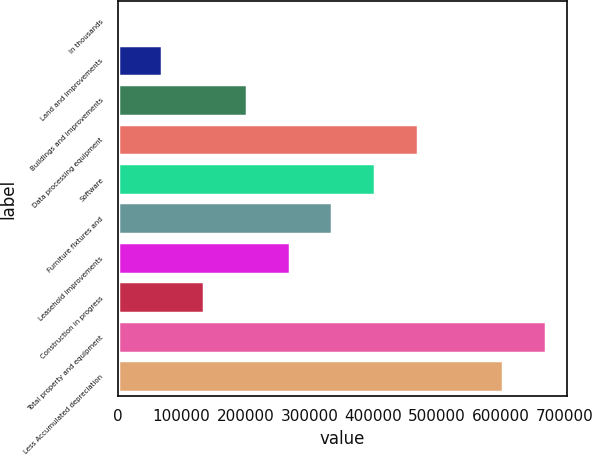Convert chart. <chart><loc_0><loc_0><loc_500><loc_500><bar_chart><fcel>In thousands<fcel>Land and improvements<fcel>Buildings and improvements<fcel>Data processing equipment<fcel>Software<fcel>Furniture fixtures and<fcel>Leasehold improvements<fcel>Construction in progress<fcel>Total property and equipment<fcel>Less Accumulated depreciation<nl><fcel>2009<fcel>68808.8<fcel>202408<fcel>469608<fcel>402808<fcel>336008<fcel>269208<fcel>135609<fcel>670007<fcel>603207<nl></chart> 